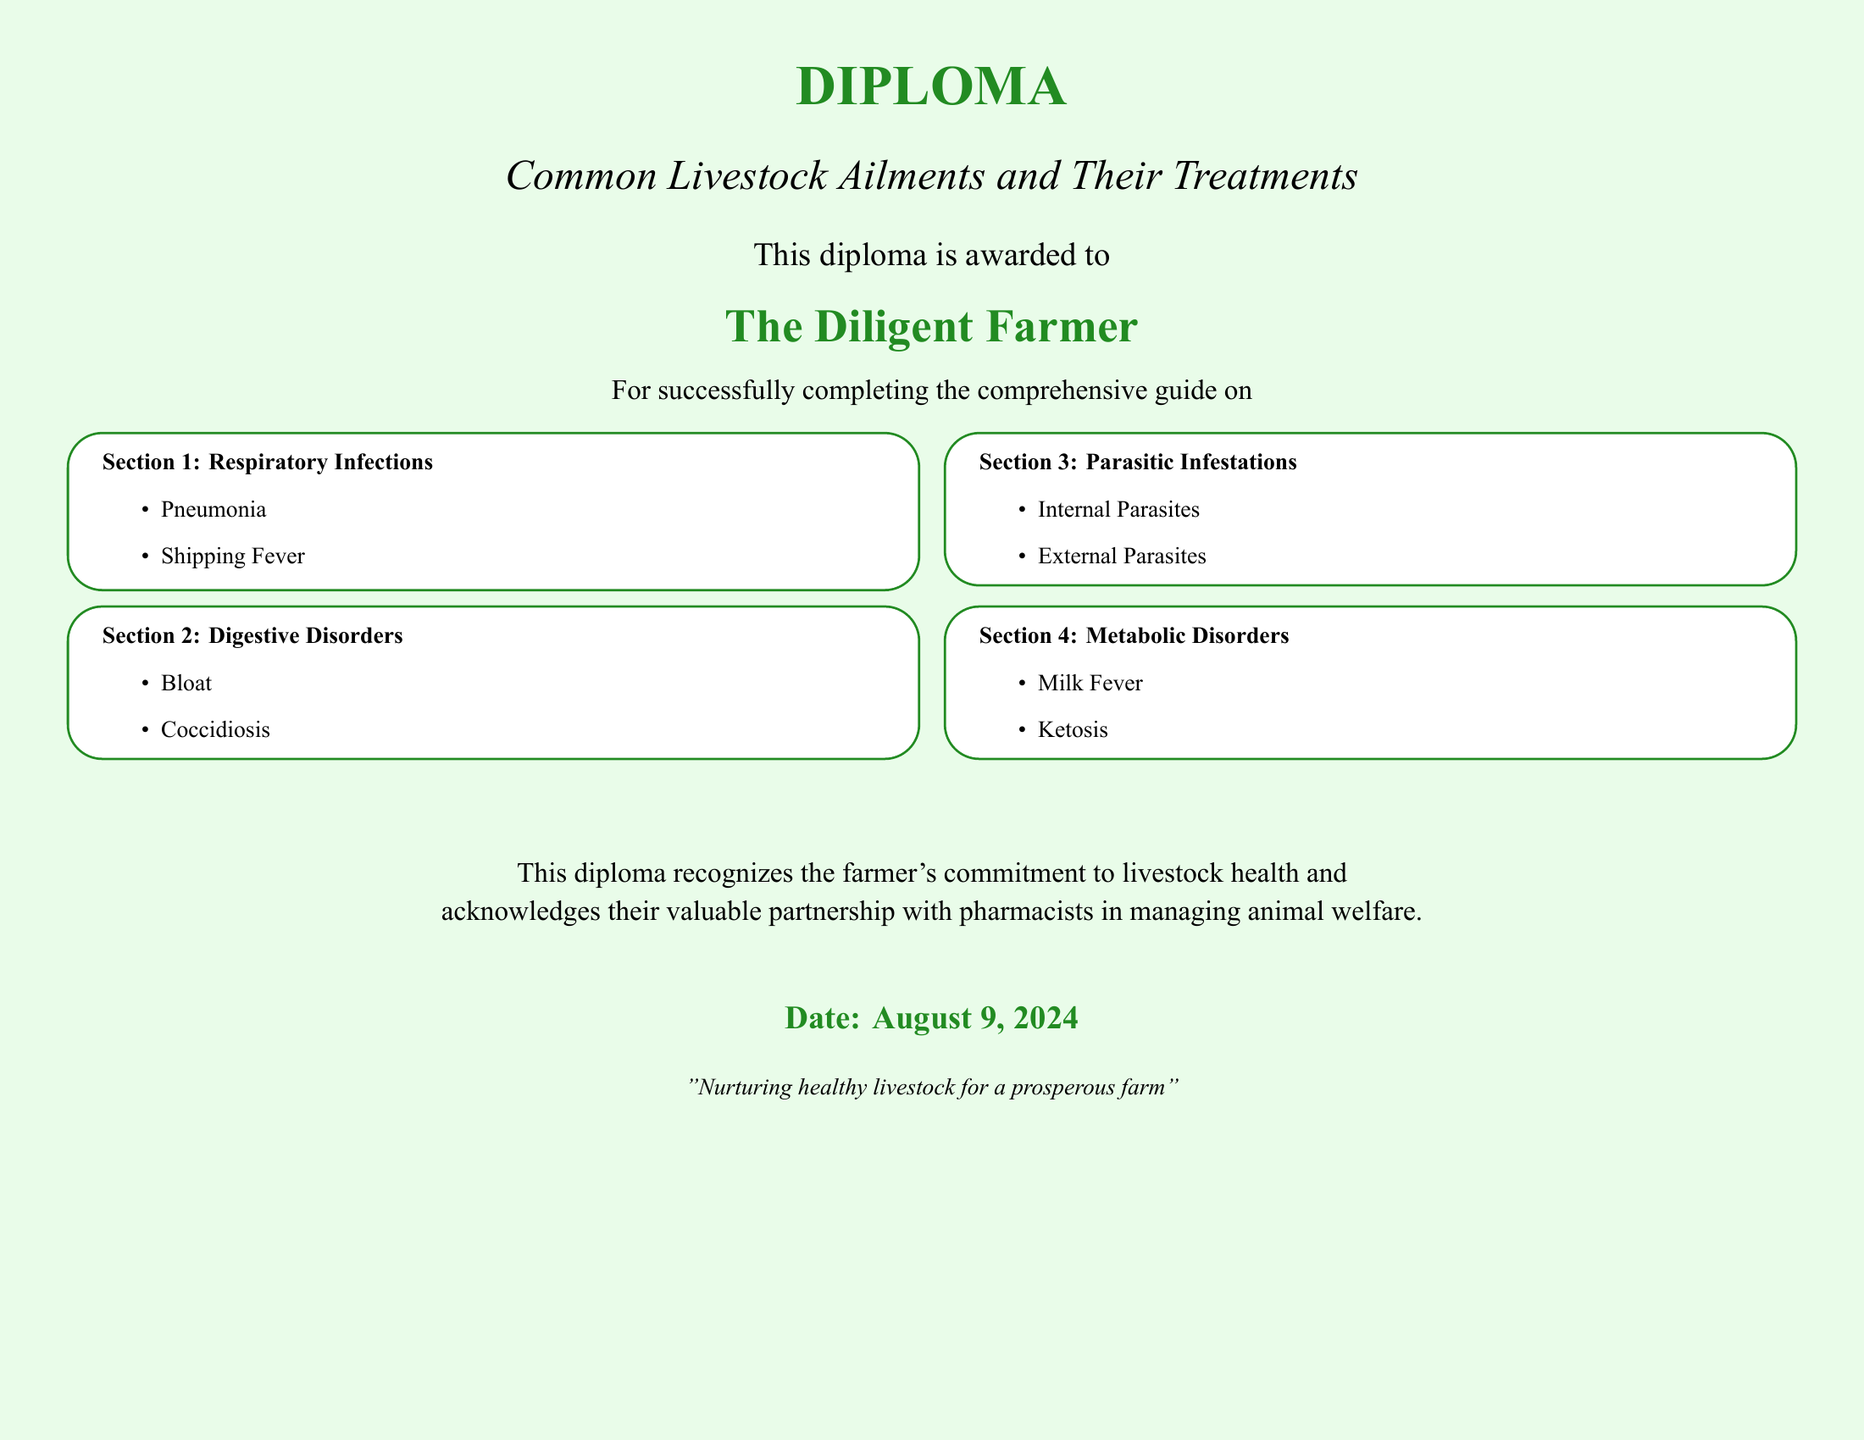what is the title of the diploma? The title of the diploma is mentioned at the beginning of the document, highlighting the focus on livestock ailments.
Answer: Common Livestock Ailments and Their Treatments who is awarded the diploma? The name mentioned in the diploma indicates the recipient of the award.
Answer: The Diligent Farmer how many sections are there in the diploma? The sections are explicitly listed in the document, which helps in determining the total count.
Answer: 4 name one respiratory infection listed in the diploma. The diploma includes specific ailments, and one is highlighted under the respiratory infections section.
Answer: Pneumonia what condition is mentioned under metabolic disorders? The section lists groups of disorders, and one specific condition is requested in this query.
Answer: Milk Fever what does the diploma recognize? The statement towards the end of the document outlines what is acknowledged besides the certification itself.
Answer: The farmer's commitment to livestock health what is the date mentioned in the diploma? The date is indicated in the document format and is set to current when rendered.
Answer: today's date what is the color of the diploma background? The background color is described within the document's details, indicating the visual design choice.
Answer: light green 